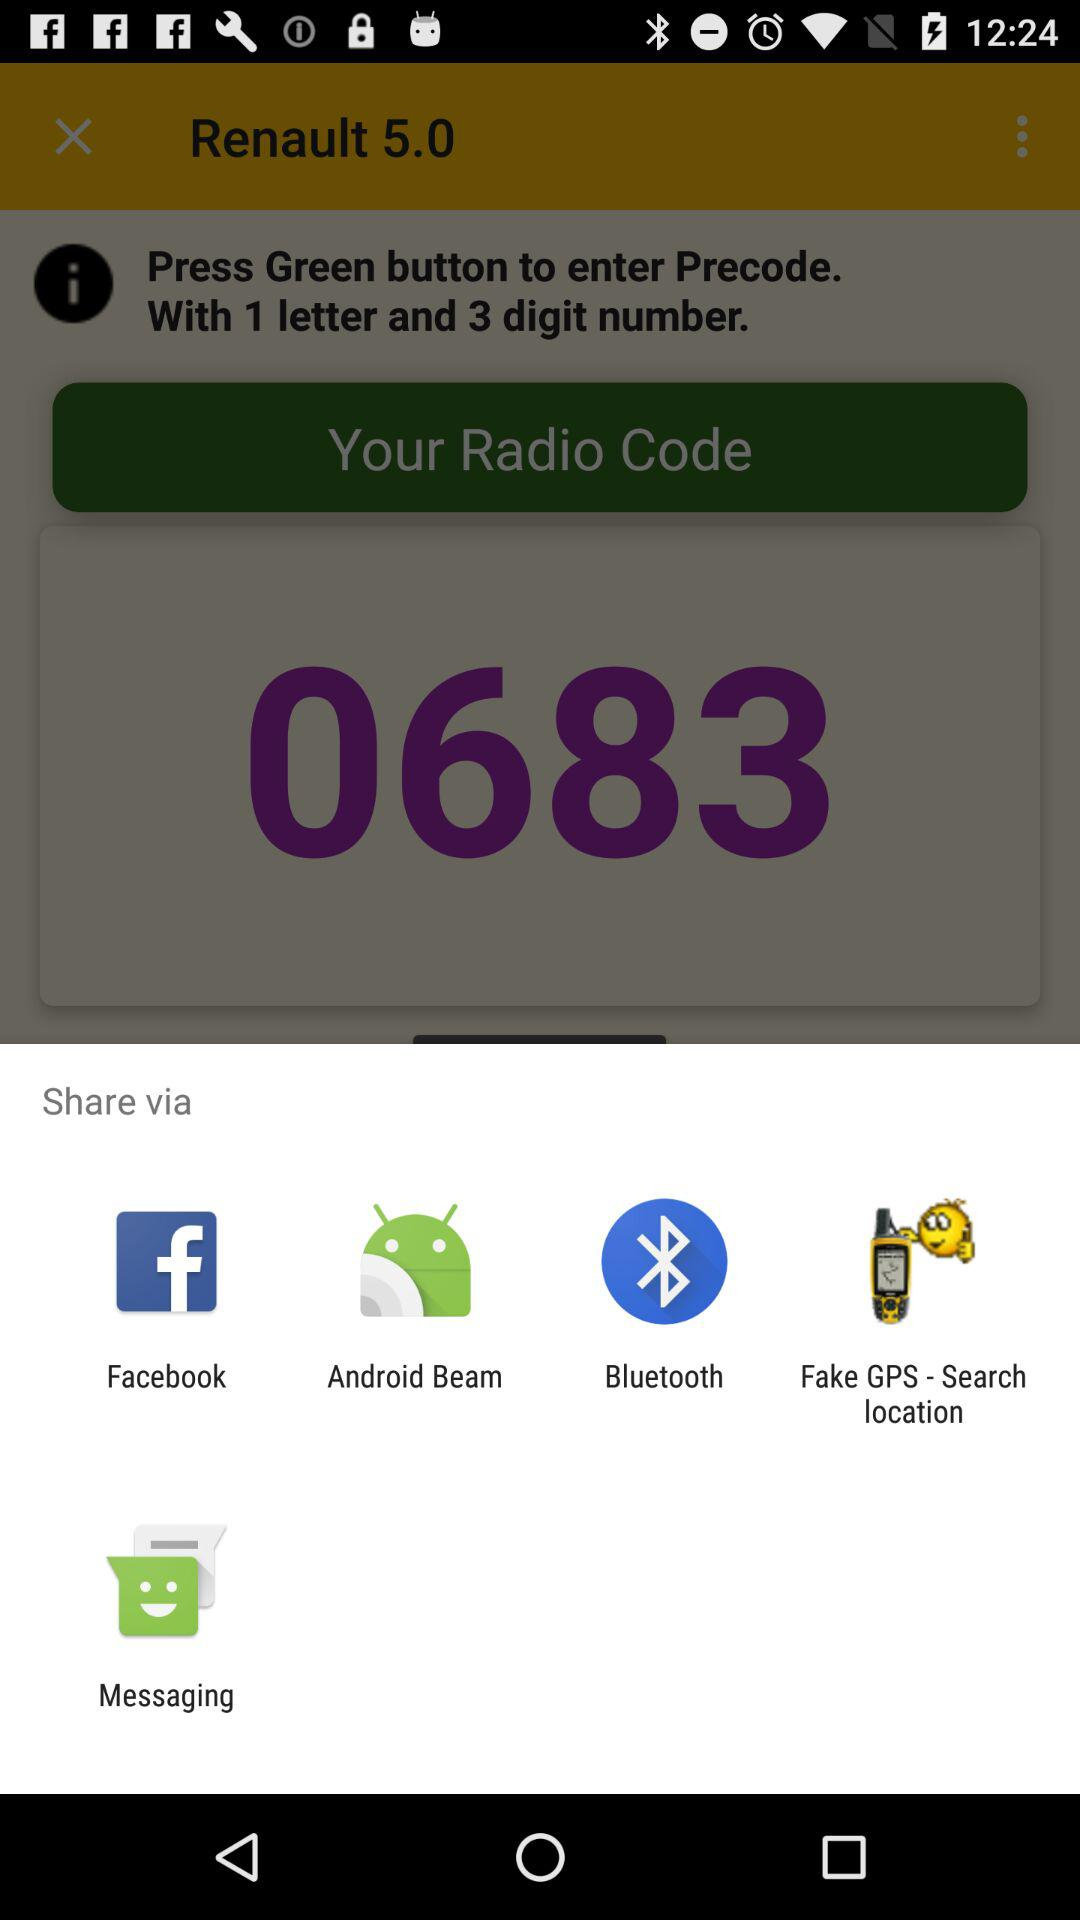Through which applications can we share the content? You can share the content through "Facebook", "Android Beam", "Bluetooth", "Fake GPS - Search location" and "Messaging". 